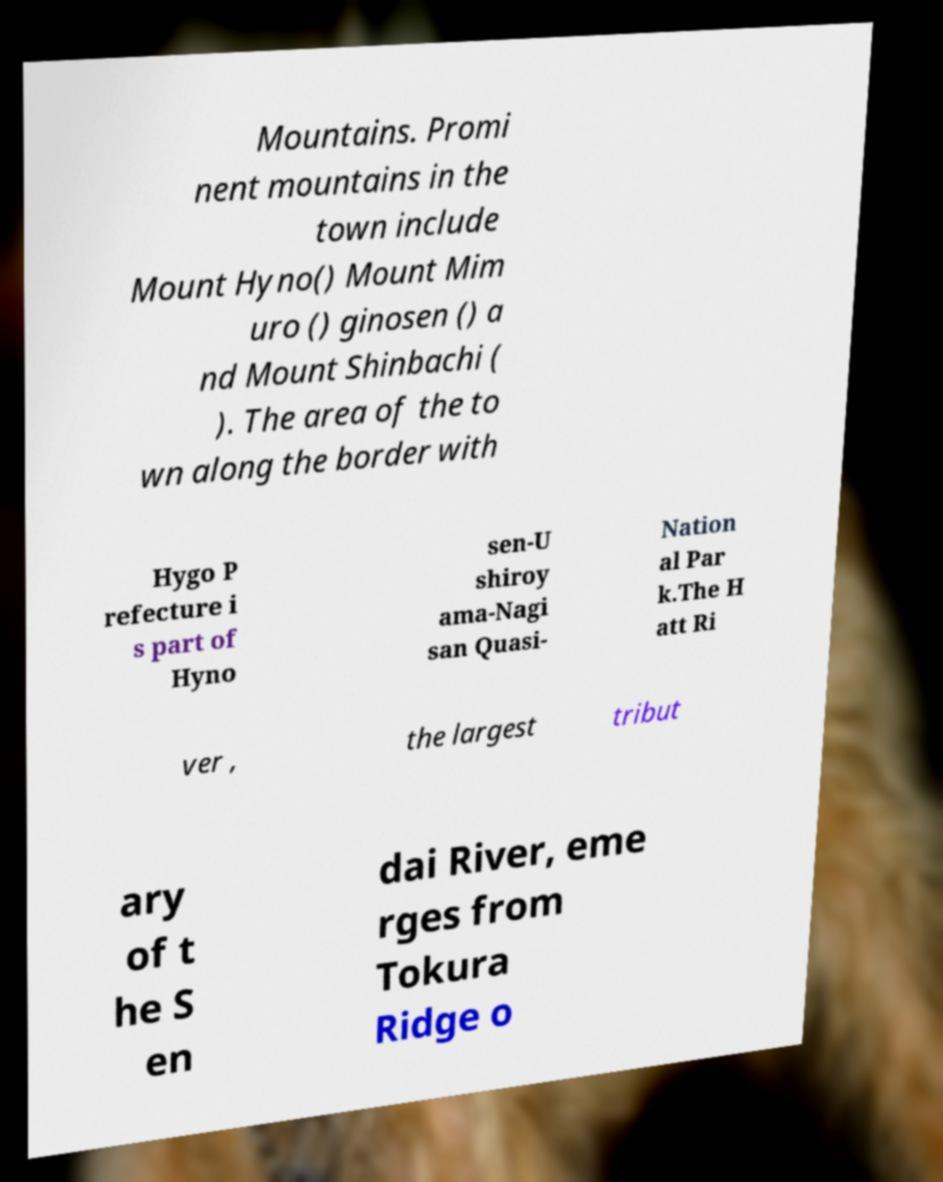Could you assist in decoding the text presented in this image and type it out clearly? Mountains. Promi nent mountains in the town include Mount Hyno() Mount Mim uro () ginosen () a nd Mount Shinbachi ( ). The area of the to wn along the border with Hygo P refecture i s part of Hyno sen-U shiroy ama-Nagi san Quasi- Nation al Par k.The H att Ri ver , the largest tribut ary of t he S en dai River, eme rges from Tokura Ridge o 